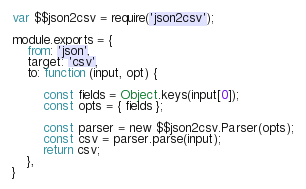<code> <loc_0><loc_0><loc_500><loc_500><_JavaScript_>var $$json2csv = require('json2csv');

module.exports = {
	from: 'json',
	target: 'csv',
	to: function (input, opt) {
 
		const fields = Object.keys(input[0]);
		const opts = { fields };
		
		const parser = new $$json2csv.Parser(opts);
		const csv = parser.parse(input);
		return csv;
	},
}</code> 